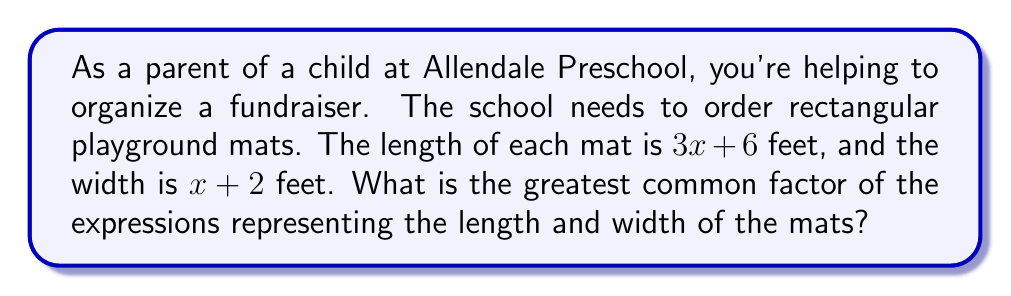Help me with this question. Let's approach this step-by-step:

1) First, let's identify the expressions for length and width:
   Length: $3x + 6$
   Width: $x + 2$

2) To find the greatest common factor (GCF), we need to factor each expression:

   Length: $3x + 6$
   $= 3(x + 2)$

   Width: $x + 2$
   $= 1(x + 2)$

3) Now we can see that $(x + 2)$ is a common factor in both expressions.

4) The coefficients are 3 and 1, which have no common factors other than 1.

5) Therefore, the greatest common factor of $3x + 6$ and $x + 2$ is $(x + 2)$.
Answer: $(x + 2)$ 